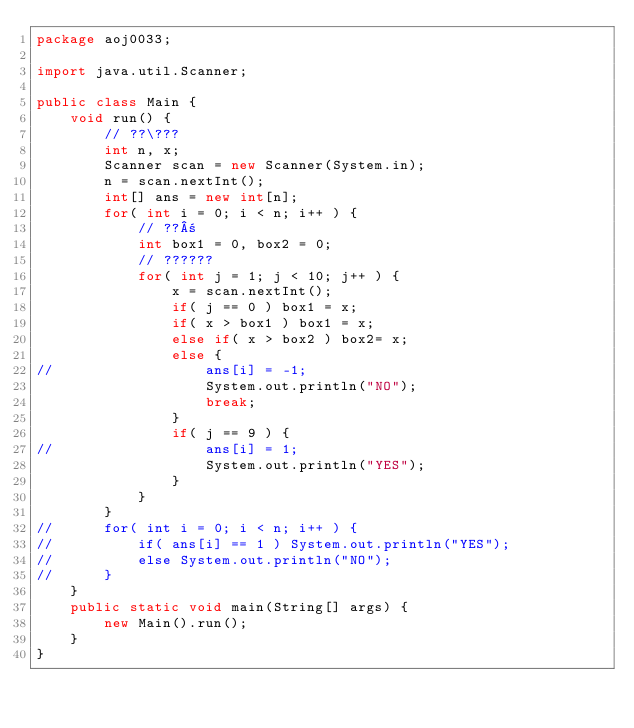Convert code to text. <code><loc_0><loc_0><loc_500><loc_500><_Java_>package aoj0033;

import java.util.Scanner;

public class Main {
	void run() {
		// ??\???
		int n, x;
		Scanner scan = new Scanner(System.in);
		n = scan.nextInt();
		int[] ans = new int[n];
		for( int i = 0; i < n; i++ ) {
			// ??±
			int box1 = 0, box2 = 0;
			// ??????
			for( int j = 1; j < 10; j++ ) {
				x = scan.nextInt();
				if( j == 0 ) box1 = x;
				if( x > box1 ) box1 = x;
				else if( x > box2 ) box2= x;
				else {
//					ans[i] = -1;
					System.out.println("NO");
					break;
				}
				if( j == 9 ) {
//					ans[i] = 1;
					System.out.println("YES");
				}
			}
		}
//		for( int i = 0; i < n; i++ ) {
//			if( ans[i] == 1 ) System.out.println("YES");
//			else System.out.println("NO");
//		}
	}
	public static void main(String[] args) {
		new Main().run();
	}
}</code> 